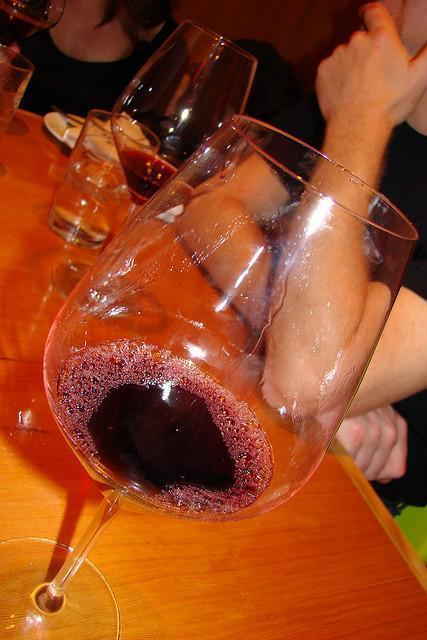How many wine glasses are visible?
Give a very brief answer. 3. How many surfboard are there?
Give a very brief answer. 0. 